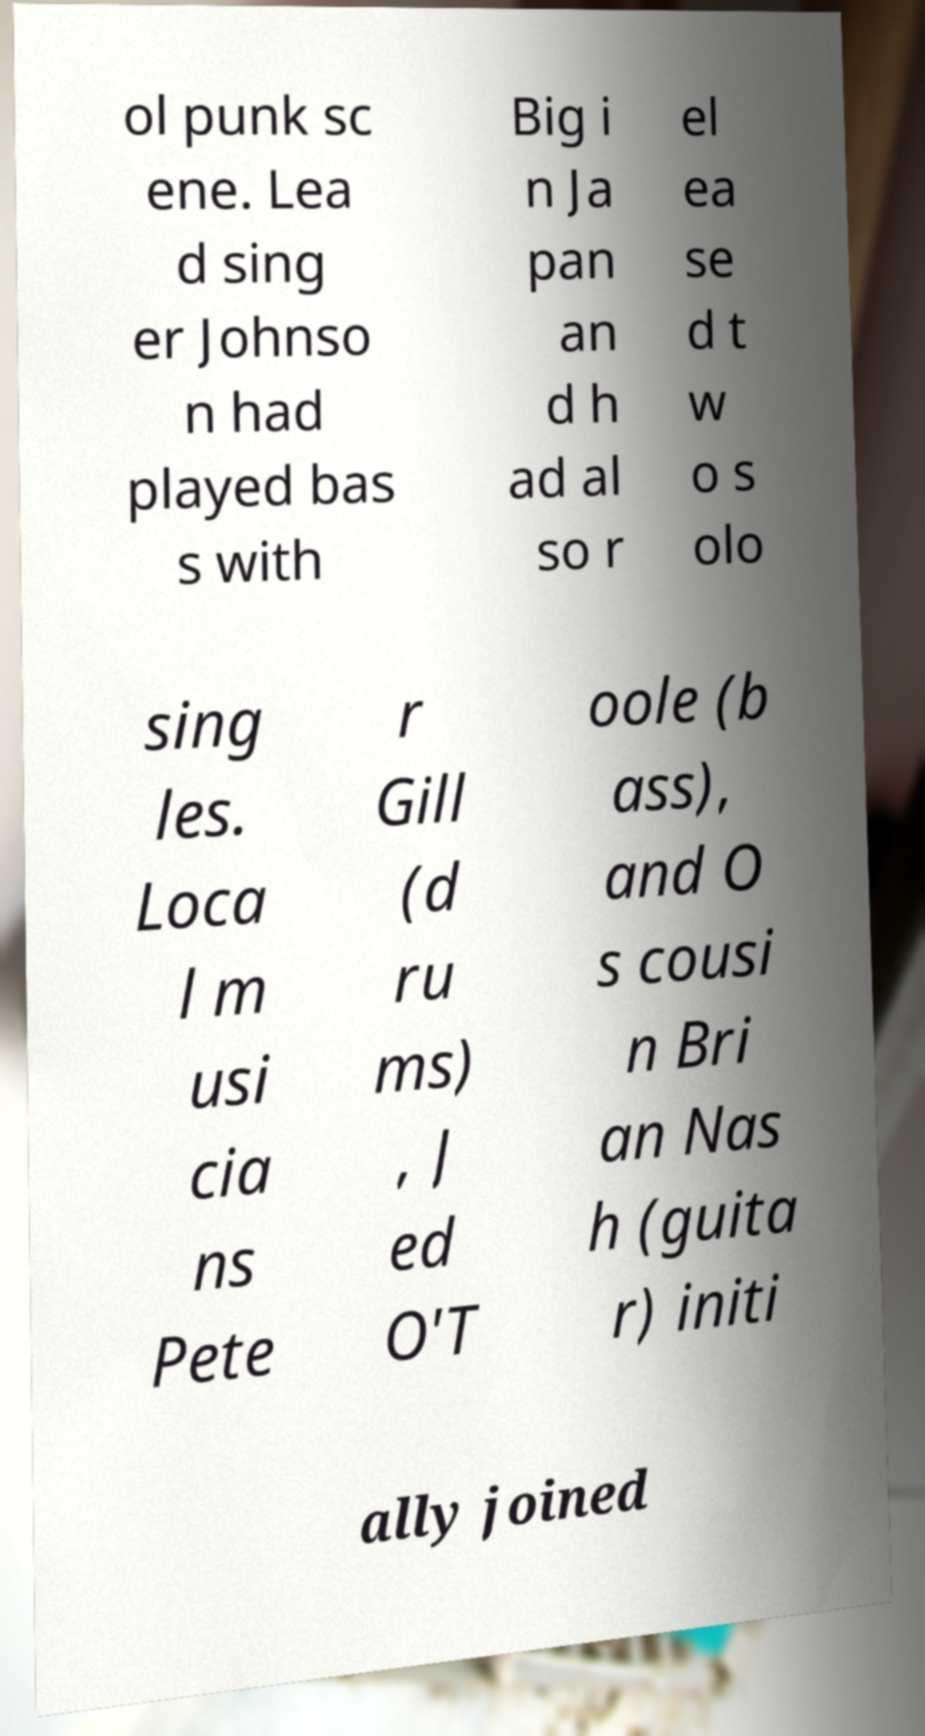I need the written content from this picture converted into text. Can you do that? ol punk sc ene. Lea d sing er Johnso n had played bas s with Big i n Ja pan an d h ad al so r el ea se d t w o s olo sing les. Loca l m usi cia ns Pete r Gill (d ru ms) , J ed O'T oole (b ass), and O s cousi n Bri an Nas h (guita r) initi ally joined 